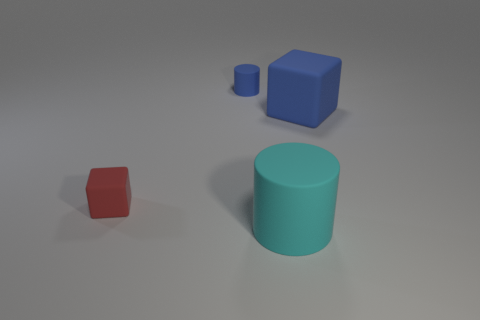How many other things have the same shape as the big cyan object?
Your response must be concise. 1. Is the blue cube made of the same material as the tiny blue cylinder?
Give a very brief answer. Yes. There is a big object that is in front of the big rubber object that is behind the small red object; what is its shape?
Keep it short and to the point. Cylinder. There is a tiny matte thing to the right of the red thing; what number of matte things are on the right side of it?
Provide a short and direct response. 2. What is the material of the thing that is behind the tiny red rubber cube and in front of the tiny cylinder?
Your answer should be compact. Rubber. The blue rubber thing that is the same size as the cyan rubber cylinder is what shape?
Give a very brief answer. Cube. There is a matte cube that is in front of the blue thing that is to the right of the cylinder that is to the right of the tiny blue rubber cylinder; what is its color?
Ensure brevity in your answer.  Red. How many objects are matte things behind the big rubber block or large brown things?
Provide a short and direct response. 1. What material is the red thing that is the same size as the blue matte cylinder?
Provide a succinct answer. Rubber. There is a blue thing to the right of the matte thing in front of the small thing that is to the left of the small blue rubber object; what is its material?
Provide a succinct answer. Rubber. 